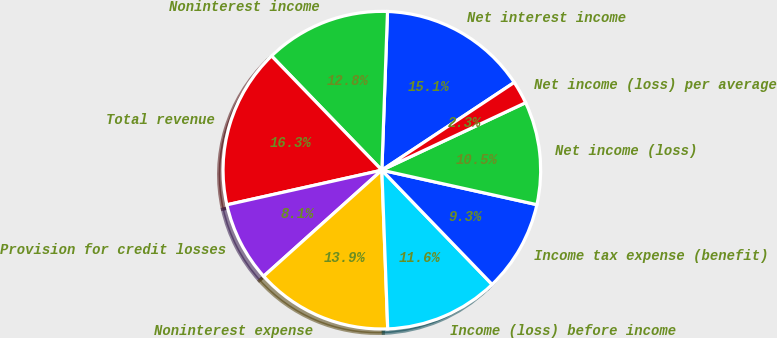Convert chart to OTSL. <chart><loc_0><loc_0><loc_500><loc_500><pie_chart><fcel>Net interest income<fcel>Noninterest income<fcel>Total revenue<fcel>Provision for credit losses<fcel>Noninterest expense<fcel>Income (loss) before income<fcel>Income tax expense (benefit)<fcel>Net income (loss)<fcel>Net income (loss) per average<nl><fcel>15.12%<fcel>12.79%<fcel>16.28%<fcel>8.14%<fcel>13.95%<fcel>11.63%<fcel>9.3%<fcel>10.47%<fcel>2.33%<nl></chart> 